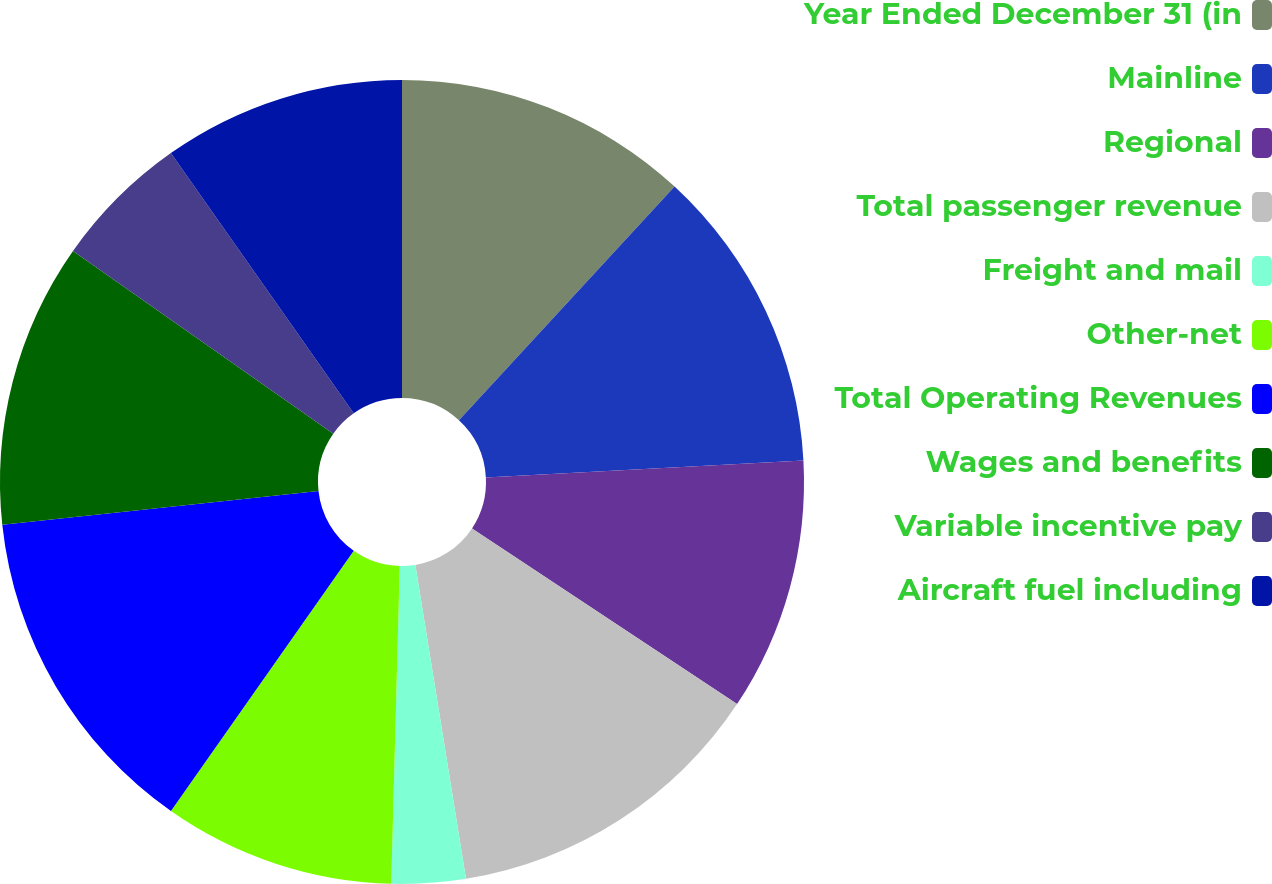Convert chart to OTSL. <chart><loc_0><loc_0><loc_500><loc_500><pie_chart><fcel>Year Ended December 31 (in<fcel>Mainline<fcel>Regional<fcel>Total passenger revenue<fcel>Freight and mail<fcel>Other-net<fcel>Total Operating Revenues<fcel>Wages and benefits<fcel>Variable incentive pay<fcel>Aircraft fuel including<nl><fcel>11.86%<fcel>12.29%<fcel>10.17%<fcel>13.14%<fcel>2.97%<fcel>9.32%<fcel>13.56%<fcel>11.44%<fcel>5.51%<fcel>9.75%<nl></chart> 